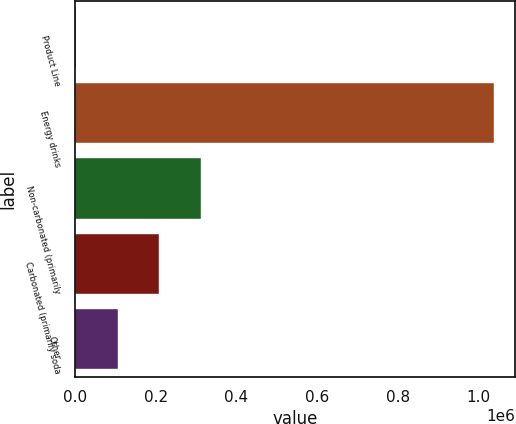Convert chart. <chart><loc_0><loc_0><loc_500><loc_500><bar_chart><fcel>Product Line<fcel>Energy drinks<fcel>Non-carbonated (primarily<fcel>Carbonated (primarily soda<fcel>Other<nl><fcel>2009<fcel>1.03857e+06<fcel>312978<fcel>209322<fcel>105665<nl></chart> 